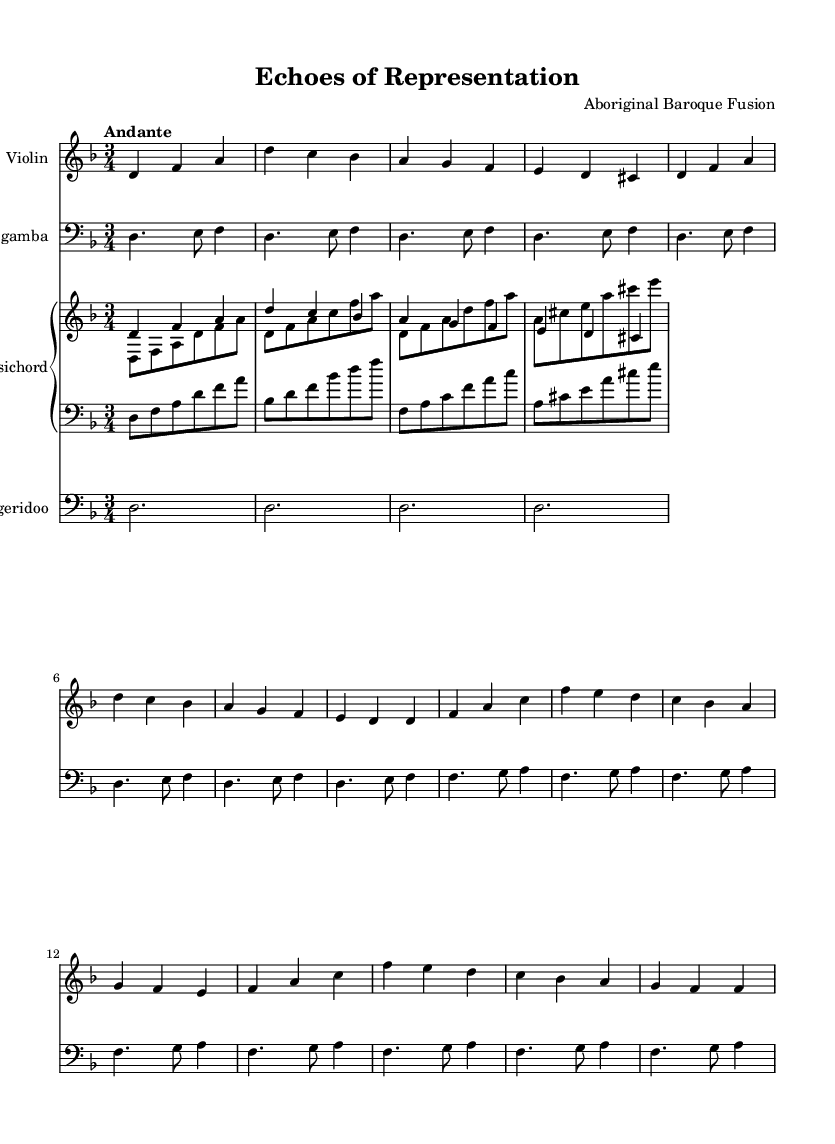What is the key signature of this music? The key signature is D minor, indicated by one flat (B flat) at the beginning of the staff.
Answer: D minor What is the time signature of the piece? The time signature shown on the sheet music is 3/4, which is typically a waltz time, indicating three beats per measure.
Answer: 3/4 What is the tempo marking for the piece? The tempo marking in the score indicates "Andante," which suggests a moderately slow pace.
Answer: Andante How many measures are in the violin part? There are 16 measures in the violin part, as counted from the beginning to the end of the line.
Answer: 16 Which instrument plays a drone-like effect in this piece? The didgeridoo plays long sustained notes that create a drone-like effect throughout the piece, contrasting with the melodic instruments.
Answer: Didgeridoo Describe the range of the viola da gamba part. The viola da gamba part primarily uses pitches that are within a lower register, as indicated by the clef and the notes played, showcasing a rich, deep sound.
Answer: Lower register How does the harpsichord contribute to the texture of the music? The harpsichord provides both harmonic support and rhythmic drive, with its right hand playing melodies and the left hand reinforcing bass notes, adding depth to the texture.
Answer: Harmonic support and rhythm 